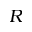Convert formula to latex. <formula><loc_0><loc_0><loc_500><loc_500>R</formula> 